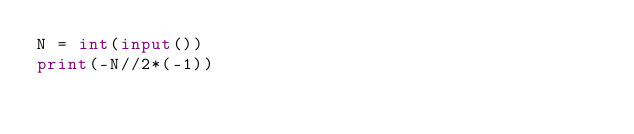Convert code to text. <code><loc_0><loc_0><loc_500><loc_500><_Python_>N = int(input())
print(-N//2*(-1))
</code> 